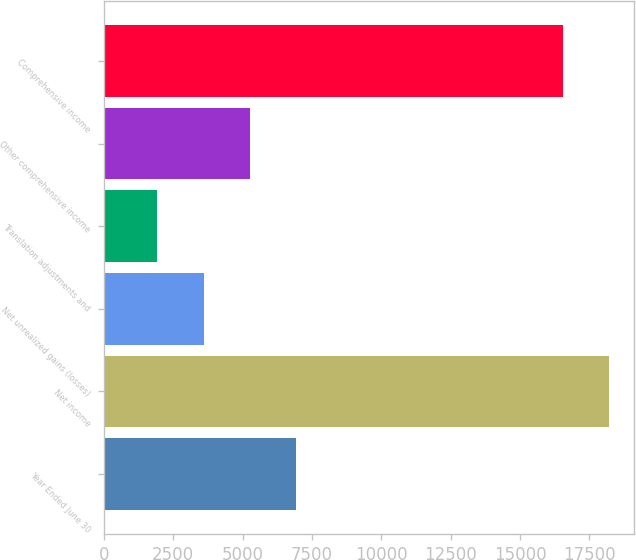Convert chart. <chart><loc_0><loc_0><loc_500><loc_500><bar_chart><fcel>Year Ended June 30<fcel>Net income<fcel>Net unrealized gains (losses)<fcel>Translation adjustments and<fcel>Other comprehensive income<fcel>Comprehensive income<nl><fcel>6944.2<fcel>18209.3<fcel>3599.6<fcel>1927.3<fcel>5271.9<fcel>16537<nl></chart> 